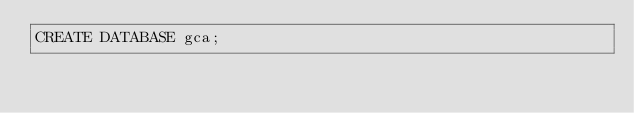Convert code to text. <code><loc_0><loc_0><loc_500><loc_500><_SQL_>CREATE DATABASE gca;</code> 